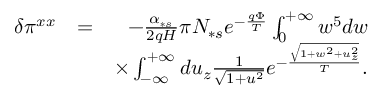Convert formula to latex. <formula><loc_0><loc_0><loc_500><loc_500>\begin{array} { r l r } { \delta \pi ^ { x x } } & { = } & { - \frac { \alpha _ { \ast s } } { 2 q H } \pi N _ { \ast s } e ^ { - \frac { q \Phi } { T } } \int _ { 0 } ^ { + \infty } w ^ { 5 } d w } \\ & { \times \int _ { - \infty } ^ { + \infty } d u _ { z } \frac { 1 } { \sqrt { 1 + u ^ { 2 } } } e ^ { - \frac { \sqrt { 1 + w ^ { 2 } + u _ { z } ^ { 2 } } } { T } } . } \end{array}</formula> 